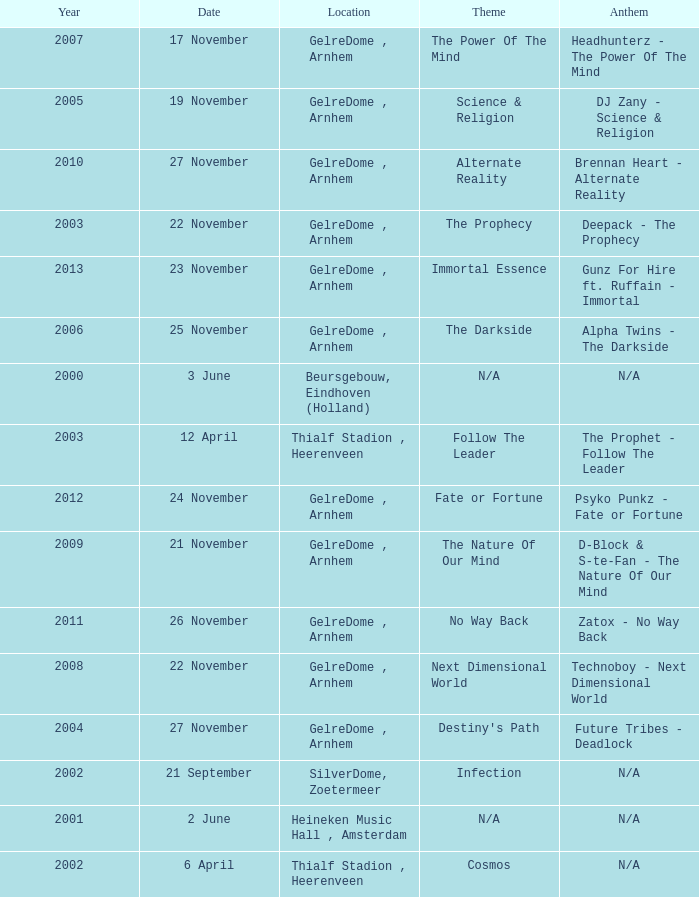What is the earliest year it was located in gelredome, arnhem, and a Anthem of technoboy - next dimensional world? 2008.0. 